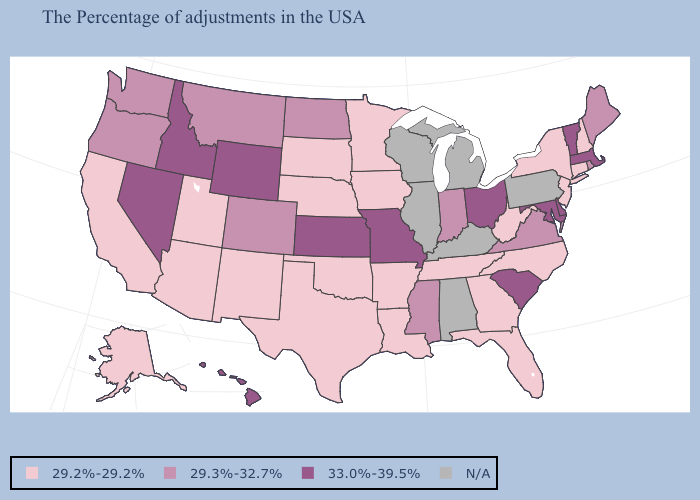Does Idaho have the highest value in the USA?
Short answer required. Yes. What is the highest value in states that border Minnesota?
Write a very short answer. 29.3%-32.7%. What is the value of Rhode Island?
Give a very brief answer. 29.3%-32.7%. Among the states that border Tennessee , does Missouri have the highest value?
Write a very short answer. Yes. Does Montana have the lowest value in the USA?
Write a very short answer. No. What is the value of Kentucky?
Concise answer only. N/A. What is the value of Mississippi?
Write a very short answer. 29.3%-32.7%. Which states have the lowest value in the USA?
Write a very short answer. New Hampshire, Connecticut, New York, New Jersey, North Carolina, West Virginia, Florida, Georgia, Tennessee, Louisiana, Arkansas, Minnesota, Iowa, Nebraska, Oklahoma, Texas, South Dakota, New Mexico, Utah, Arizona, California, Alaska. Among the states that border North Dakota , does South Dakota have the lowest value?
Concise answer only. Yes. Name the states that have a value in the range 29.2%-29.2%?
Give a very brief answer. New Hampshire, Connecticut, New York, New Jersey, North Carolina, West Virginia, Florida, Georgia, Tennessee, Louisiana, Arkansas, Minnesota, Iowa, Nebraska, Oklahoma, Texas, South Dakota, New Mexico, Utah, Arizona, California, Alaska. Does Hawaii have the highest value in the USA?
Give a very brief answer. Yes. What is the value of Ohio?
Be succinct. 33.0%-39.5%. Name the states that have a value in the range 29.2%-29.2%?
Give a very brief answer. New Hampshire, Connecticut, New York, New Jersey, North Carolina, West Virginia, Florida, Georgia, Tennessee, Louisiana, Arkansas, Minnesota, Iowa, Nebraska, Oklahoma, Texas, South Dakota, New Mexico, Utah, Arizona, California, Alaska. What is the value of Alabama?
Quick response, please. N/A. 